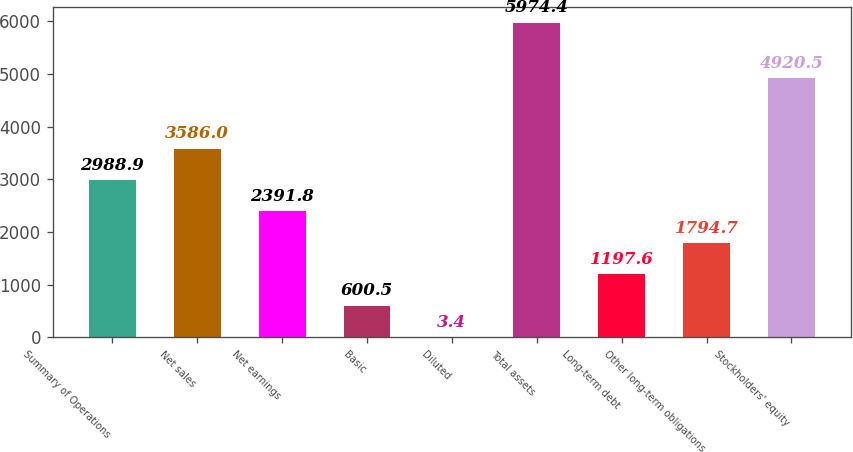Convert chart to OTSL. <chart><loc_0><loc_0><loc_500><loc_500><bar_chart><fcel>Summary of Operations<fcel>Net sales<fcel>Net earnings<fcel>Basic<fcel>Diluted<fcel>Total assets<fcel>Long-term debt<fcel>Other long-term obligations<fcel>Stockholders' equity<nl><fcel>2988.9<fcel>3586<fcel>2391.8<fcel>600.5<fcel>3.4<fcel>5974.4<fcel>1197.6<fcel>1794.7<fcel>4920.5<nl></chart> 